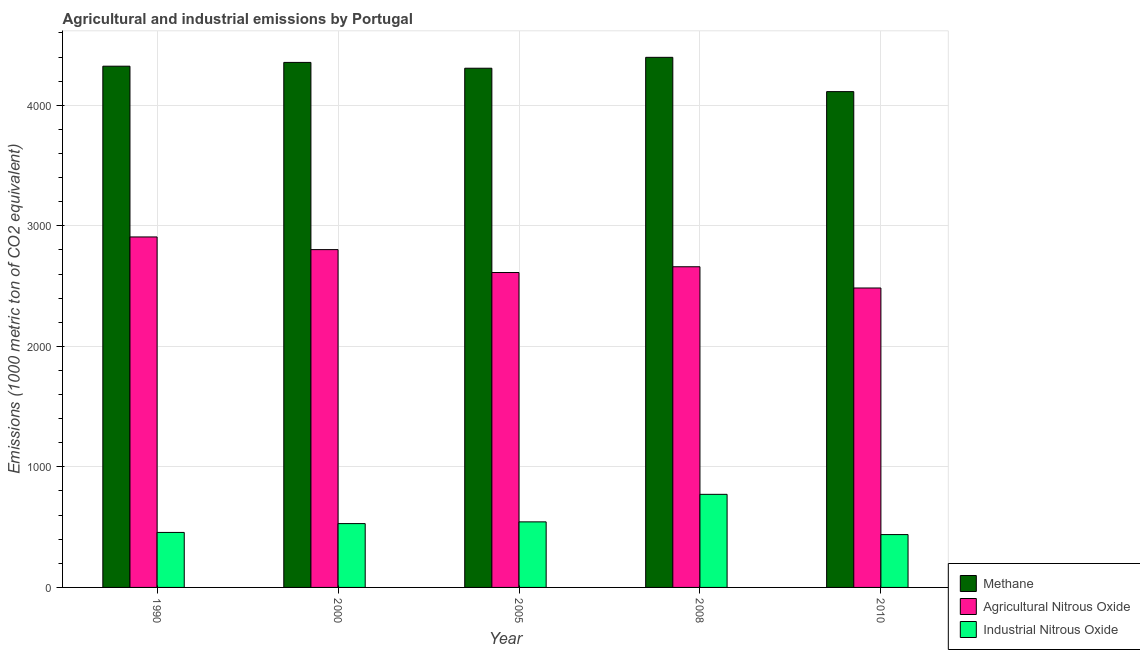How many different coloured bars are there?
Give a very brief answer. 3. How many groups of bars are there?
Ensure brevity in your answer.  5. Are the number of bars per tick equal to the number of legend labels?
Give a very brief answer. Yes. Are the number of bars on each tick of the X-axis equal?
Give a very brief answer. Yes. How many bars are there on the 4th tick from the right?
Ensure brevity in your answer.  3. What is the amount of industrial nitrous oxide emissions in 2010?
Your response must be concise. 438.4. Across all years, what is the maximum amount of industrial nitrous oxide emissions?
Provide a succinct answer. 772.3. Across all years, what is the minimum amount of methane emissions?
Your response must be concise. 4113.1. In which year was the amount of industrial nitrous oxide emissions maximum?
Make the answer very short. 2008. In which year was the amount of methane emissions minimum?
Ensure brevity in your answer.  2010. What is the total amount of methane emissions in the graph?
Your response must be concise. 2.15e+04. What is the difference between the amount of industrial nitrous oxide emissions in 2000 and that in 2008?
Ensure brevity in your answer.  -242.8. What is the difference between the amount of industrial nitrous oxide emissions in 2000 and the amount of agricultural nitrous oxide emissions in 2008?
Keep it short and to the point. -242.8. What is the average amount of agricultural nitrous oxide emissions per year?
Keep it short and to the point. 2693.3. In the year 1990, what is the difference between the amount of methane emissions and amount of industrial nitrous oxide emissions?
Provide a succinct answer. 0. What is the ratio of the amount of methane emissions in 1990 to that in 2005?
Your answer should be compact. 1. Is the amount of methane emissions in 1990 less than that in 2010?
Keep it short and to the point. No. Is the difference between the amount of industrial nitrous oxide emissions in 2000 and 2005 greater than the difference between the amount of methane emissions in 2000 and 2005?
Your answer should be compact. No. What is the difference between the highest and the second highest amount of methane emissions?
Provide a succinct answer. 42.2. What is the difference between the highest and the lowest amount of industrial nitrous oxide emissions?
Provide a short and direct response. 333.9. In how many years, is the amount of industrial nitrous oxide emissions greater than the average amount of industrial nitrous oxide emissions taken over all years?
Make the answer very short. 1. Is the sum of the amount of industrial nitrous oxide emissions in 1990 and 2000 greater than the maximum amount of methane emissions across all years?
Offer a terse response. Yes. What does the 2nd bar from the left in 2005 represents?
Give a very brief answer. Agricultural Nitrous Oxide. What does the 3rd bar from the right in 2008 represents?
Your answer should be compact. Methane. Is it the case that in every year, the sum of the amount of methane emissions and amount of agricultural nitrous oxide emissions is greater than the amount of industrial nitrous oxide emissions?
Your answer should be compact. Yes. Are the values on the major ticks of Y-axis written in scientific E-notation?
Ensure brevity in your answer.  No. Does the graph contain grids?
Offer a very short reply. Yes. Where does the legend appear in the graph?
Offer a terse response. Bottom right. What is the title of the graph?
Provide a short and direct response. Agricultural and industrial emissions by Portugal. Does "Taxes on goods and services" appear as one of the legend labels in the graph?
Your answer should be very brief. No. What is the label or title of the Y-axis?
Ensure brevity in your answer.  Emissions (1000 metric ton of CO2 equivalent). What is the Emissions (1000 metric ton of CO2 equivalent) of Methane in 1990?
Offer a very short reply. 4324.1. What is the Emissions (1000 metric ton of CO2 equivalent) in Agricultural Nitrous Oxide in 1990?
Provide a short and direct response. 2907.5. What is the Emissions (1000 metric ton of CO2 equivalent) in Industrial Nitrous Oxide in 1990?
Offer a terse response. 456.2. What is the Emissions (1000 metric ton of CO2 equivalent) in Methane in 2000?
Provide a succinct answer. 4355.4. What is the Emissions (1000 metric ton of CO2 equivalent) of Agricultural Nitrous Oxide in 2000?
Ensure brevity in your answer.  2802.4. What is the Emissions (1000 metric ton of CO2 equivalent) in Industrial Nitrous Oxide in 2000?
Your answer should be compact. 529.5. What is the Emissions (1000 metric ton of CO2 equivalent) of Methane in 2005?
Your answer should be compact. 4307.2. What is the Emissions (1000 metric ton of CO2 equivalent) of Agricultural Nitrous Oxide in 2005?
Offer a very short reply. 2612.4. What is the Emissions (1000 metric ton of CO2 equivalent) of Industrial Nitrous Oxide in 2005?
Your response must be concise. 543.9. What is the Emissions (1000 metric ton of CO2 equivalent) of Methane in 2008?
Ensure brevity in your answer.  4397.6. What is the Emissions (1000 metric ton of CO2 equivalent) of Agricultural Nitrous Oxide in 2008?
Offer a terse response. 2660.2. What is the Emissions (1000 metric ton of CO2 equivalent) of Industrial Nitrous Oxide in 2008?
Your response must be concise. 772.3. What is the Emissions (1000 metric ton of CO2 equivalent) in Methane in 2010?
Provide a short and direct response. 4113.1. What is the Emissions (1000 metric ton of CO2 equivalent) in Agricultural Nitrous Oxide in 2010?
Offer a very short reply. 2484. What is the Emissions (1000 metric ton of CO2 equivalent) in Industrial Nitrous Oxide in 2010?
Provide a short and direct response. 438.4. Across all years, what is the maximum Emissions (1000 metric ton of CO2 equivalent) of Methane?
Your response must be concise. 4397.6. Across all years, what is the maximum Emissions (1000 metric ton of CO2 equivalent) in Agricultural Nitrous Oxide?
Keep it short and to the point. 2907.5. Across all years, what is the maximum Emissions (1000 metric ton of CO2 equivalent) of Industrial Nitrous Oxide?
Make the answer very short. 772.3. Across all years, what is the minimum Emissions (1000 metric ton of CO2 equivalent) in Methane?
Offer a very short reply. 4113.1. Across all years, what is the minimum Emissions (1000 metric ton of CO2 equivalent) in Agricultural Nitrous Oxide?
Your response must be concise. 2484. Across all years, what is the minimum Emissions (1000 metric ton of CO2 equivalent) in Industrial Nitrous Oxide?
Keep it short and to the point. 438.4. What is the total Emissions (1000 metric ton of CO2 equivalent) in Methane in the graph?
Keep it short and to the point. 2.15e+04. What is the total Emissions (1000 metric ton of CO2 equivalent) in Agricultural Nitrous Oxide in the graph?
Keep it short and to the point. 1.35e+04. What is the total Emissions (1000 metric ton of CO2 equivalent) in Industrial Nitrous Oxide in the graph?
Your response must be concise. 2740.3. What is the difference between the Emissions (1000 metric ton of CO2 equivalent) in Methane in 1990 and that in 2000?
Keep it short and to the point. -31.3. What is the difference between the Emissions (1000 metric ton of CO2 equivalent) in Agricultural Nitrous Oxide in 1990 and that in 2000?
Make the answer very short. 105.1. What is the difference between the Emissions (1000 metric ton of CO2 equivalent) in Industrial Nitrous Oxide in 1990 and that in 2000?
Keep it short and to the point. -73.3. What is the difference between the Emissions (1000 metric ton of CO2 equivalent) of Methane in 1990 and that in 2005?
Offer a terse response. 16.9. What is the difference between the Emissions (1000 metric ton of CO2 equivalent) in Agricultural Nitrous Oxide in 1990 and that in 2005?
Ensure brevity in your answer.  295.1. What is the difference between the Emissions (1000 metric ton of CO2 equivalent) of Industrial Nitrous Oxide in 1990 and that in 2005?
Keep it short and to the point. -87.7. What is the difference between the Emissions (1000 metric ton of CO2 equivalent) of Methane in 1990 and that in 2008?
Offer a very short reply. -73.5. What is the difference between the Emissions (1000 metric ton of CO2 equivalent) of Agricultural Nitrous Oxide in 1990 and that in 2008?
Your answer should be compact. 247.3. What is the difference between the Emissions (1000 metric ton of CO2 equivalent) of Industrial Nitrous Oxide in 1990 and that in 2008?
Your answer should be compact. -316.1. What is the difference between the Emissions (1000 metric ton of CO2 equivalent) of Methane in 1990 and that in 2010?
Keep it short and to the point. 211. What is the difference between the Emissions (1000 metric ton of CO2 equivalent) of Agricultural Nitrous Oxide in 1990 and that in 2010?
Offer a terse response. 423.5. What is the difference between the Emissions (1000 metric ton of CO2 equivalent) in Methane in 2000 and that in 2005?
Your response must be concise. 48.2. What is the difference between the Emissions (1000 metric ton of CO2 equivalent) of Agricultural Nitrous Oxide in 2000 and that in 2005?
Your answer should be compact. 190. What is the difference between the Emissions (1000 metric ton of CO2 equivalent) in Industrial Nitrous Oxide in 2000 and that in 2005?
Give a very brief answer. -14.4. What is the difference between the Emissions (1000 metric ton of CO2 equivalent) of Methane in 2000 and that in 2008?
Your response must be concise. -42.2. What is the difference between the Emissions (1000 metric ton of CO2 equivalent) in Agricultural Nitrous Oxide in 2000 and that in 2008?
Keep it short and to the point. 142.2. What is the difference between the Emissions (1000 metric ton of CO2 equivalent) of Industrial Nitrous Oxide in 2000 and that in 2008?
Your response must be concise. -242.8. What is the difference between the Emissions (1000 metric ton of CO2 equivalent) of Methane in 2000 and that in 2010?
Give a very brief answer. 242.3. What is the difference between the Emissions (1000 metric ton of CO2 equivalent) in Agricultural Nitrous Oxide in 2000 and that in 2010?
Keep it short and to the point. 318.4. What is the difference between the Emissions (1000 metric ton of CO2 equivalent) of Industrial Nitrous Oxide in 2000 and that in 2010?
Give a very brief answer. 91.1. What is the difference between the Emissions (1000 metric ton of CO2 equivalent) in Methane in 2005 and that in 2008?
Provide a short and direct response. -90.4. What is the difference between the Emissions (1000 metric ton of CO2 equivalent) in Agricultural Nitrous Oxide in 2005 and that in 2008?
Make the answer very short. -47.8. What is the difference between the Emissions (1000 metric ton of CO2 equivalent) in Industrial Nitrous Oxide in 2005 and that in 2008?
Your response must be concise. -228.4. What is the difference between the Emissions (1000 metric ton of CO2 equivalent) of Methane in 2005 and that in 2010?
Give a very brief answer. 194.1. What is the difference between the Emissions (1000 metric ton of CO2 equivalent) of Agricultural Nitrous Oxide in 2005 and that in 2010?
Your answer should be compact. 128.4. What is the difference between the Emissions (1000 metric ton of CO2 equivalent) of Industrial Nitrous Oxide in 2005 and that in 2010?
Provide a short and direct response. 105.5. What is the difference between the Emissions (1000 metric ton of CO2 equivalent) in Methane in 2008 and that in 2010?
Provide a short and direct response. 284.5. What is the difference between the Emissions (1000 metric ton of CO2 equivalent) in Agricultural Nitrous Oxide in 2008 and that in 2010?
Ensure brevity in your answer.  176.2. What is the difference between the Emissions (1000 metric ton of CO2 equivalent) of Industrial Nitrous Oxide in 2008 and that in 2010?
Offer a terse response. 333.9. What is the difference between the Emissions (1000 metric ton of CO2 equivalent) of Methane in 1990 and the Emissions (1000 metric ton of CO2 equivalent) of Agricultural Nitrous Oxide in 2000?
Make the answer very short. 1521.7. What is the difference between the Emissions (1000 metric ton of CO2 equivalent) of Methane in 1990 and the Emissions (1000 metric ton of CO2 equivalent) of Industrial Nitrous Oxide in 2000?
Your answer should be very brief. 3794.6. What is the difference between the Emissions (1000 metric ton of CO2 equivalent) of Agricultural Nitrous Oxide in 1990 and the Emissions (1000 metric ton of CO2 equivalent) of Industrial Nitrous Oxide in 2000?
Keep it short and to the point. 2378. What is the difference between the Emissions (1000 metric ton of CO2 equivalent) of Methane in 1990 and the Emissions (1000 metric ton of CO2 equivalent) of Agricultural Nitrous Oxide in 2005?
Give a very brief answer. 1711.7. What is the difference between the Emissions (1000 metric ton of CO2 equivalent) of Methane in 1990 and the Emissions (1000 metric ton of CO2 equivalent) of Industrial Nitrous Oxide in 2005?
Your answer should be very brief. 3780.2. What is the difference between the Emissions (1000 metric ton of CO2 equivalent) of Agricultural Nitrous Oxide in 1990 and the Emissions (1000 metric ton of CO2 equivalent) of Industrial Nitrous Oxide in 2005?
Offer a very short reply. 2363.6. What is the difference between the Emissions (1000 metric ton of CO2 equivalent) in Methane in 1990 and the Emissions (1000 metric ton of CO2 equivalent) in Agricultural Nitrous Oxide in 2008?
Make the answer very short. 1663.9. What is the difference between the Emissions (1000 metric ton of CO2 equivalent) in Methane in 1990 and the Emissions (1000 metric ton of CO2 equivalent) in Industrial Nitrous Oxide in 2008?
Provide a succinct answer. 3551.8. What is the difference between the Emissions (1000 metric ton of CO2 equivalent) of Agricultural Nitrous Oxide in 1990 and the Emissions (1000 metric ton of CO2 equivalent) of Industrial Nitrous Oxide in 2008?
Make the answer very short. 2135.2. What is the difference between the Emissions (1000 metric ton of CO2 equivalent) of Methane in 1990 and the Emissions (1000 metric ton of CO2 equivalent) of Agricultural Nitrous Oxide in 2010?
Offer a terse response. 1840.1. What is the difference between the Emissions (1000 metric ton of CO2 equivalent) of Methane in 1990 and the Emissions (1000 metric ton of CO2 equivalent) of Industrial Nitrous Oxide in 2010?
Make the answer very short. 3885.7. What is the difference between the Emissions (1000 metric ton of CO2 equivalent) in Agricultural Nitrous Oxide in 1990 and the Emissions (1000 metric ton of CO2 equivalent) in Industrial Nitrous Oxide in 2010?
Offer a very short reply. 2469.1. What is the difference between the Emissions (1000 metric ton of CO2 equivalent) of Methane in 2000 and the Emissions (1000 metric ton of CO2 equivalent) of Agricultural Nitrous Oxide in 2005?
Make the answer very short. 1743. What is the difference between the Emissions (1000 metric ton of CO2 equivalent) of Methane in 2000 and the Emissions (1000 metric ton of CO2 equivalent) of Industrial Nitrous Oxide in 2005?
Keep it short and to the point. 3811.5. What is the difference between the Emissions (1000 metric ton of CO2 equivalent) in Agricultural Nitrous Oxide in 2000 and the Emissions (1000 metric ton of CO2 equivalent) in Industrial Nitrous Oxide in 2005?
Your answer should be compact. 2258.5. What is the difference between the Emissions (1000 metric ton of CO2 equivalent) in Methane in 2000 and the Emissions (1000 metric ton of CO2 equivalent) in Agricultural Nitrous Oxide in 2008?
Keep it short and to the point. 1695.2. What is the difference between the Emissions (1000 metric ton of CO2 equivalent) of Methane in 2000 and the Emissions (1000 metric ton of CO2 equivalent) of Industrial Nitrous Oxide in 2008?
Make the answer very short. 3583.1. What is the difference between the Emissions (1000 metric ton of CO2 equivalent) in Agricultural Nitrous Oxide in 2000 and the Emissions (1000 metric ton of CO2 equivalent) in Industrial Nitrous Oxide in 2008?
Keep it short and to the point. 2030.1. What is the difference between the Emissions (1000 metric ton of CO2 equivalent) in Methane in 2000 and the Emissions (1000 metric ton of CO2 equivalent) in Agricultural Nitrous Oxide in 2010?
Your response must be concise. 1871.4. What is the difference between the Emissions (1000 metric ton of CO2 equivalent) of Methane in 2000 and the Emissions (1000 metric ton of CO2 equivalent) of Industrial Nitrous Oxide in 2010?
Offer a very short reply. 3917. What is the difference between the Emissions (1000 metric ton of CO2 equivalent) in Agricultural Nitrous Oxide in 2000 and the Emissions (1000 metric ton of CO2 equivalent) in Industrial Nitrous Oxide in 2010?
Ensure brevity in your answer.  2364. What is the difference between the Emissions (1000 metric ton of CO2 equivalent) of Methane in 2005 and the Emissions (1000 metric ton of CO2 equivalent) of Agricultural Nitrous Oxide in 2008?
Your answer should be very brief. 1647. What is the difference between the Emissions (1000 metric ton of CO2 equivalent) in Methane in 2005 and the Emissions (1000 metric ton of CO2 equivalent) in Industrial Nitrous Oxide in 2008?
Keep it short and to the point. 3534.9. What is the difference between the Emissions (1000 metric ton of CO2 equivalent) of Agricultural Nitrous Oxide in 2005 and the Emissions (1000 metric ton of CO2 equivalent) of Industrial Nitrous Oxide in 2008?
Ensure brevity in your answer.  1840.1. What is the difference between the Emissions (1000 metric ton of CO2 equivalent) of Methane in 2005 and the Emissions (1000 metric ton of CO2 equivalent) of Agricultural Nitrous Oxide in 2010?
Offer a terse response. 1823.2. What is the difference between the Emissions (1000 metric ton of CO2 equivalent) of Methane in 2005 and the Emissions (1000 metric ton of CO2 equivalent) of Industrial Nitrous Oxide in 2010?
Ensure brevity in your answer.  3868.8. What is the difference between the Emissions (1000 metric ton of CO2 equivalent) of Agricultural Nitrous Oxide in 2005 and the Emissions (1000 metric ton of CO2 equivalent) of Industrial Nitrous Oxide in 2010?
Provide a short and direct response. 2174. What is the difference between the Emissions (1000 metric ton of CO2 equivalent) in Methane in 2008 and the Emissions (1000 metric ton of CO2 equivalent) in Agricultural Nitrous Oxide in 2010?
Your answer should be very brief. 1913.6. What is the difference between the Emissions (1000 metric ton of CO2 equivalent) of Methane in 2008 and the Emissions (1000 metric ton of CO2 equivalent) of Industrial Nitrous Oxide in 2010?
Provide a succinct answer. 3959.2. What is the difference between the Emissions (1000 metric ton of CO2 equivalent) in Agricultural Nitrous Oxide in 2008 and the Emissions (1000 metric ton of CO2 equivalent) in Industrial Nitrous Oxide in 2010?
Give a very brief answer. 2221.8. What is the average Emissions (1000 metric ton of CO2 equivalent) of Methane per year?
Your answer should be very brief. 4299.48. What is the average Emissions (1000 metric ton of CO2 equivalent) in Agricultural Nitrous Oxide per year?
Your answer should be very brief. 2693.3. What is the average Emissions (1000 metric ton of CO2 equivalent) of Industrial Nitrous Oxide per year?
Give a very brief answer. 548.06. In the year 1990, what is the difference between the Emissions (1000 metric ton of CO2 equivalent) of Methane and Emissions (1000 metric ton of CO2 equivalent) of Agricultural Nitrous Oxide?
Your response must be concise. 1416.6. In the year 1990, what is the difference between the Emissions (1000 metric ton of CO2 equivalent) in Methane and Emissions (1000 metric ton of CO2 equivalent) in Industrial Nitrous Oxide?
Make the answer very short. 3867.9. In the year 1990, what is the difference between the Emissions (1000 metric ton of CO2 equivalent) of Agricultural Nitrous Oxide and Emissions (1000 metric ton of CO2 equivalent) of Industrial Nitrous Oxide?
Keep it short and to the point. 2451.3. In the year 2000, what is the difference between the Emissions (1000 metric ton of CO2 equivalent) in Methane and Emissions (1000 metric ton of CO2 equivalent) in Agricultural Nitrous Oxide?
Give a very brief answer. 1553. In the year 2000, what is the difference between the Emissions (1000 metric ton of CO2 equivalent) in Methane and Emissions (1000 metric ton of CO2 equivalent) in Industrial Nitrous Oxide?
Provide a short and direct response. 3825.9. In the year 2000, what is the difference between the Emissions (1000 metric ton of CO2 equivalent) of Agricultural Nitrous Oxide and Emissions (1000 metric ton of CO2 equivalent) of Industrial Nitrous Oxide?
Make the answer very short. 2272.9. In the year 2005, what is the difference between the Emissions (1000 metric ton of CO2 equivalent) in Methane and Emissions (1000 metric ton of CO2 equivalent) in Agricultural Nitrous Oxide?
Make the answer very short. 1694.8. In the year 2005, what is the difference between the Emissions (1000 metric ton of CO2 equivalent) in Methane and Emissions (1000 metric ton of CO2 equivalent) in Industrial Nitrous Oxide?
Your answer should be very brief. 3763.3. In the year 2005, what is the difference between the Emissions (1000 metric ton of CO2 equivalent) in Agricultural Nitrous Oxide and Emissions (1000 metric ton of CO2 equivalent) in Industrial Nitrous Oxide?
Give a very brief answer. 2068.5. In the year 2008, what is the difference between the Emissions (1000 metric ton of CO2 equivalent) in Methane and Emissions (1000 metric ton of CO2 equivalent) in Agricultural Nitrous Oxide?
Ensure brevity in your answer.  1737.4. In the year 2008, what is the difference between the Emissions (1000 metric ton of CO2 equivalent) of Methane and Emissions (1000 metric ton of CO2 equivalent) of Industrial Nitrous Oxide?
Keep it short and to the point. 3625.3. In the year 2008, what is the difference between the Emissions (1000 metric ton of CO2 equivalent) in Agricultural Nitrous Oxide and Emissions (1000 metric ton of CO2 equivalent) in Industrial Nitrous Oxide?
Keep it short and to the point. 1887.9. In the year 2010, what is the difference between the Emissions (1000 metric ton of CO2 equivalent) of Methane and Emissions (1000 metric ton of CO2 equivalent) of Agricultural Nitrous Oxide?
Ensure brevity in your answer.  1629.1. In the year 2010, what is the difference between the Emissions (1000 metric ton of CO2 equivalent) in Methane and Emissions (1000 metric ton of CO2 equivalent) in Industrial Nitrous Oxide?
Offer a terse response. 3674.7. In the year 2010, what is the difference between the Emissions (1000 metric ton of CO2 equivalent) of Agricultural Nitrous Oxide and Emissions (1000 metric ton of CO2 equivalent) of Industrial Nitrous Oxide?
Make the answer very short. 2045.6. What is the ratio of the Emissions (1000 metric ton of CO2 equivalent) in Agricultural Nitrous Oxide in 1990 to that in 2000?
Offer a very short reply. 1.04. What is the ratio of the Emissions (1000 metric ton of CO2 equivalent) in Industrial Nitrous Oxide in 1990 to that in 2000?
Your answer should be very brief. 0.86. What is the ratio of the Emissions (1000 metric ton of CO2 equivalent) in Agricultural Nitrous Oxide in 1990 to that in 2005?
Provide a succinct answer. 1.11. What is the ratio of the Emissions (1000 metric ton of CO2 equivalent) of Industrial Nitrous Oxide in 1990 to that in 2005?
Your answer should be very brief. 0.84. What is the ratio of the Emissions (1000 metric ton of CO2 equivalent) in Methane in 1990 to that in 2008?
Give a very brief answer. 0.98. What is the ratio of the Emissions (1000 metric ton of CO2 equivalent) in Agricultural Nitrous Oxide in 1990 to that in 2008?
Your answer should be compact. 1.09. What is the ratio of the Emissions (1000 metric ton of CO2 equivalent) in Industrial Nitrous Oxide in 1990 to that in 2008?
Provide a succinct answer. 0.59. What is the ratio of the Emissions (1000 metric ton of CO2 equivalent) of Methane in 1990 to that in 2010?
Provide a succinct answer. 1.05. What is the ratio of the Emissions (1000 metric ton of CO2 equivalent) of Agricultural Nitrous Oxide in 1990 to that in 2010?
Ensure brevity in your answer.  1.17. What is the ratio of the Emissions (1000 metric ton of CO2 equivalent) of Industrial Nitrous Oxide in 1990 to that in 2010?
Offer a very short reply. 1.04. What is the ratio of the Emissions (1000 metric ton of CO2 equivalent) of Methane in 2000 to that in 2005?
Give a very brief answer. 1.01. What is the ratio of the Emissions (1000 metric ton of CO2 equivalent) of Agricultural Nitrous Oxide in 2000 to that in 2005?
Your response must be concise. 1.07. What is the ratio of the Emissions (1000 metric ton of CO2 equivalent) in Industrial Nitrous Oxide in 2000 to that in 2005?
Your response must be concise. 0.97. What is the ratio of the Emissions (1000 metric ton of CO2 equivalent) in Agricultural Nitrous Oxide in 2000 to that in 2008?
Keep it short and to the point. 1.05. What is the ratio of the Emissions (1000 metric ton of CO2 equivalent) in Industrial Nitrous Oxide in 2000 to that in 2008?
Keep it short and to the point. 0.69. What is the ratio of the Emissions (1000 metric ton of CO2 equivalent) in Methane in 2000 to that in 2010?
Ensure brevity in your answer.  1.06. What is the ratio of the Emissions (1000 metric ton of CO2 equivalent) in Agricultural Nitrous Oxide in 2000 to that in 2010?
Your answer should be compact. 1.13. What is the ratio of the Emissions (1000 metric ton of CO2 equivalent) in Industrial Nitrous Oxide in 2000 to that in 2010?
Offer a terse response. 1.21. What is the ratio of the Emissions (1000 metric ton of CO2 equivalent) of Methane in 2005 to that in 2008?
Provide a succinct answer. 0.98. What is the ratio of the Emissions (1000 metric ton of CO2 equivalent) in Industrial Nitrous Oxide in 2005 to that in 2008?
Offer a terse response. 0.7. What is the ratio of the Emissions (1000 metric ton of CO2 equivalent) of Methane in 2005 to that in 2010?
Your answer should be very brief. 1.05. What is the ratio of the Emissions (1000 metric ton of CO2 equivalent) in Agricultural Nitrous Oxide in 2005 to that in 2010?
Your answer should be very brief. 1.05. What is the ratio of the Emissions (1000 metric ton of CO2 equivalent) in Industrial Nitrous Oxide in 2005 to that in 2010?
Provide a succinct answer. 1.24. What is the ratio of the Emissions (1000 metric ton of CO2 equivalent) of Methane in 2008 to that in 2010?
Your answer should be very brief. 1.07. What is the ratio of the Emissions (1000 metric ton of CO2 equivalent) in Agricultural Nitrous Oxide in 2008 to that in 2010?
Give a very brief answer. 1.07. What is the ratio of the Emissions (1000 metric ton of CO2 equivalent) in Industrial Nitrous Oxide in 2008 to that in 2010?
Give a very brief answer. 1.76. What is the difference between the highest and the second highest Emissions (1000 metric ton of CO2 equivalent) in Methane?
Offer a very short reply. 42.2. What is the difference between the highest and the second highest Emissions (1000 metric ton of CO2 equivalent) in Agricultural Nitrous Oxide?
Ensure brevity in your answer.  105.1. What is the difference between the highest and the second highest Emissions (1000 metric ton of CO2 equivalent) in Industrial Nitrous Oxide?
Provide a succinct answer. 228.4. What is the difference between the highest and the lowest Emissions (1000 metric ton of CO2 equivalent) in Methane?
Give a very brief answer. 284.5. What is the difference between the highest and the lowest Emissions (1000 metric ton of CO2 equivalent) in Agricultural Nitrous Oxide?
Your answer should be compact. 423.5. What is the difference between the highest and the lowest Emissions (1000 metric ton of CO2 equivalent) in Industrial Nitrous Oxide?
Make the answer very short. 333.9. 